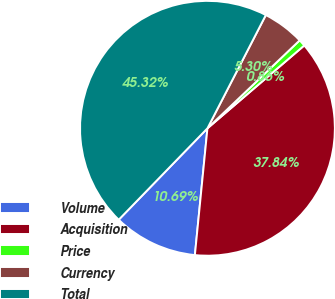Convert chart to OTSL. <chart><loc_0><loc_0><loc_500><loc_500><pie_chart><fcel>Volume<fcel>Acquisition<fcel>Price<fcel>Currency<fcel>Total<nl><fcel>10.69%<fcel>37.84%<fcel>0.86%<fcel>5.3%<fcel>45.32%<nl></chart> 